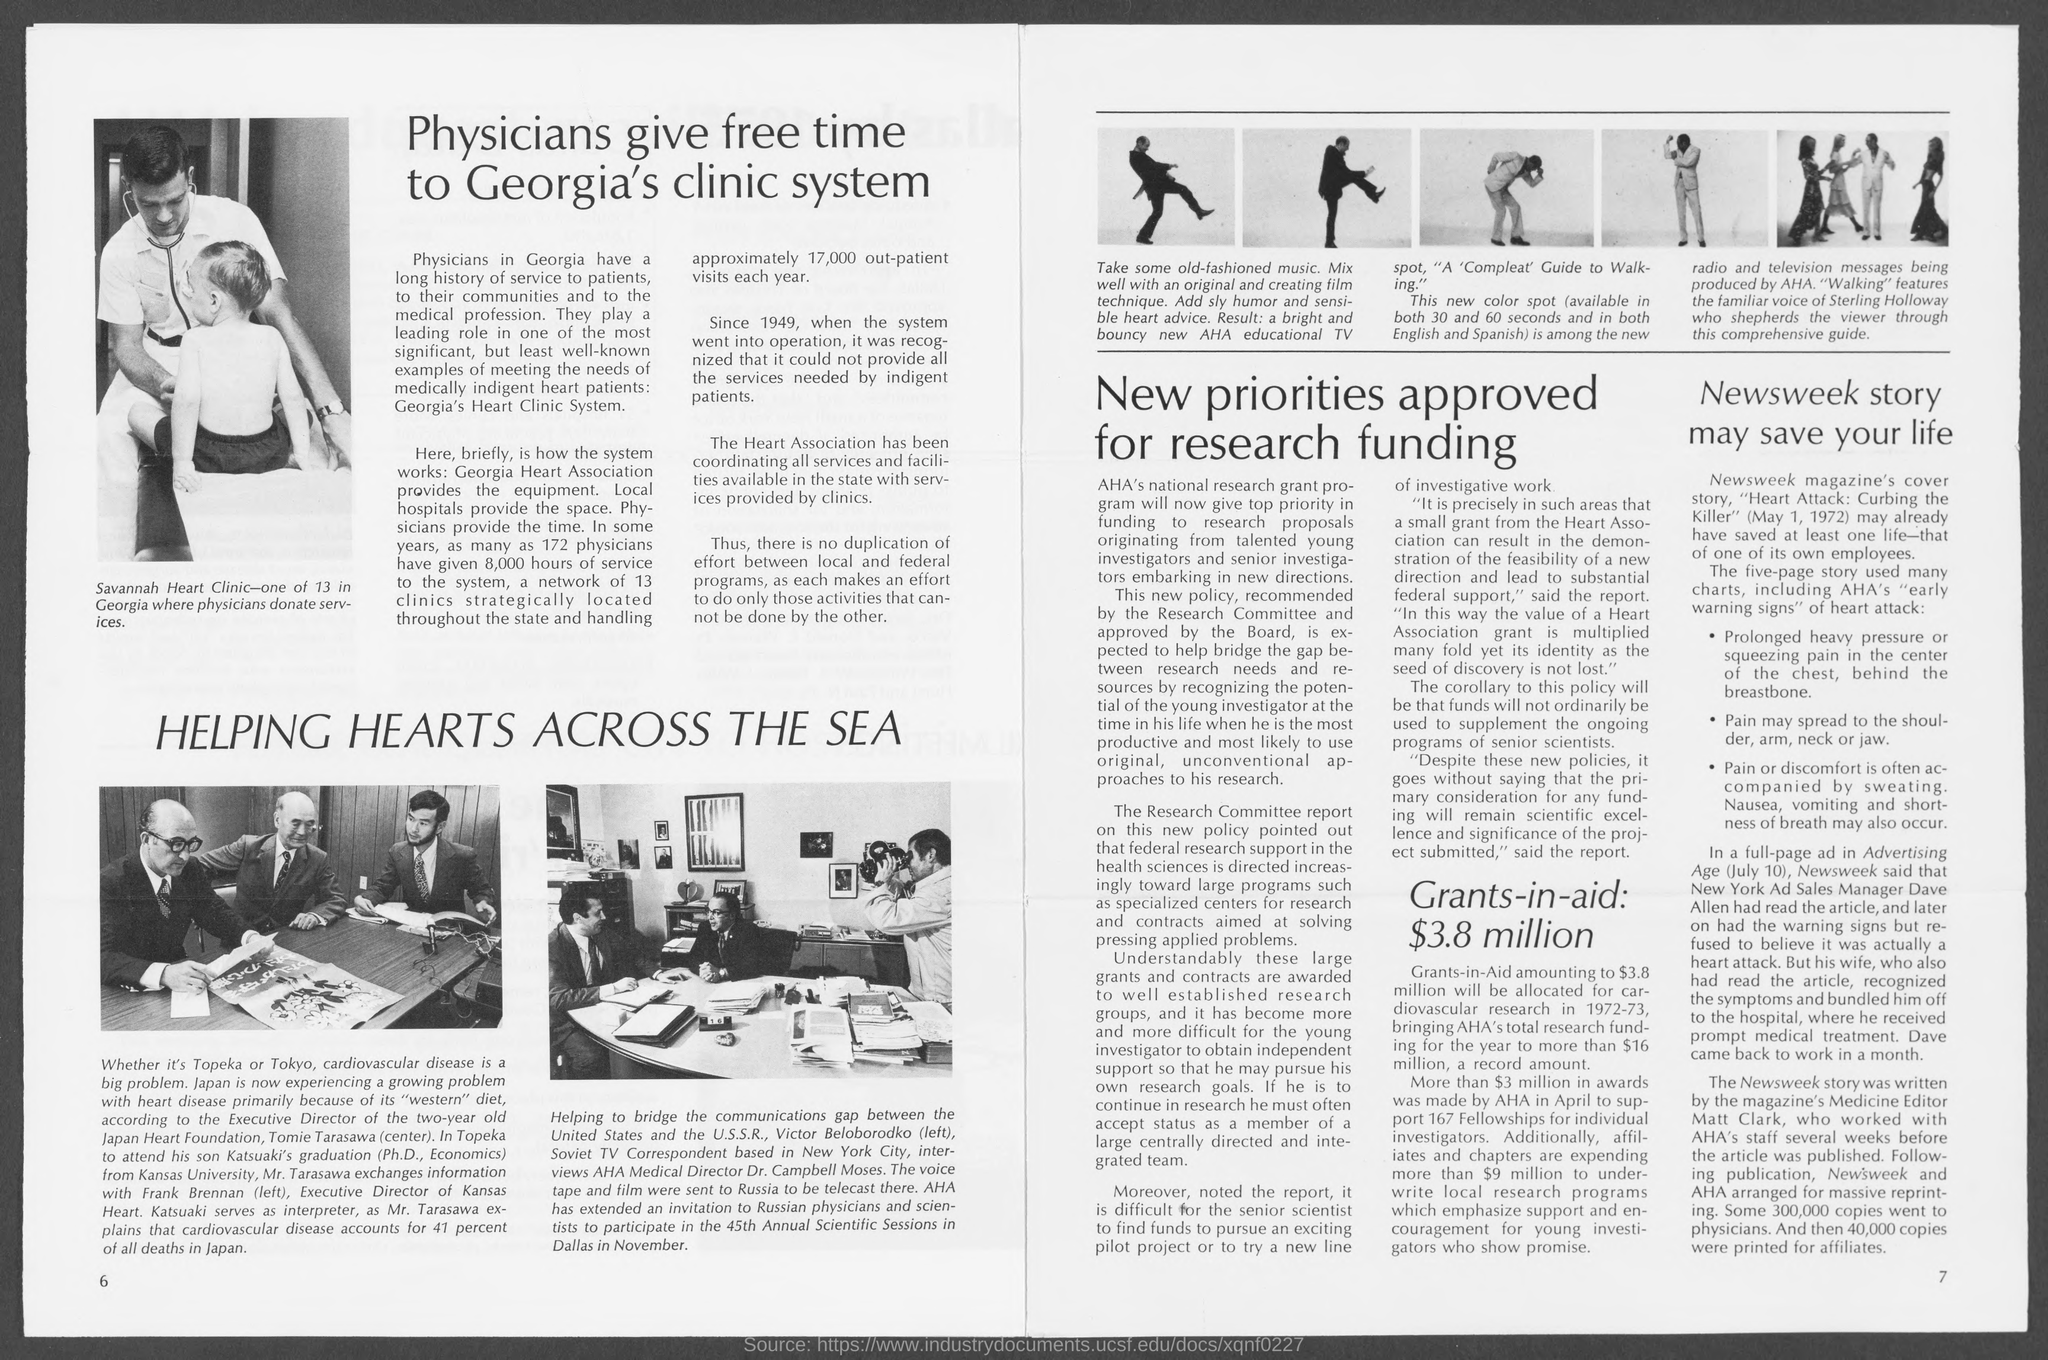Who provides the equipment for Georgia's Heart Clinic System?
Your answer should be very brief. Georgia heart association. How many clinics are there in the system mentioned in the document?
Keep it short and to the point. 13. How much time of service 172 physicians have given to the system?
Make the answer very short. 8,000 hours. Who is the Executive director of Japan Heart Foundation?
Your answer should be very brief. Tomie Tarasawa. Who is the executive director of Kansas Heart?
Your answer should be very brief. Frank Brennan. What is the name of Tomie Tarasawa's son?
Your answer should be compact. Katsuaki. Whose familiar voice is featured in "Walking"?
Offer a very short reply. Sterling Holloway. What is the name of the Medicine Editor who wrote the Newsweek story?
Keep it short and to the point. Sterling holloway. 